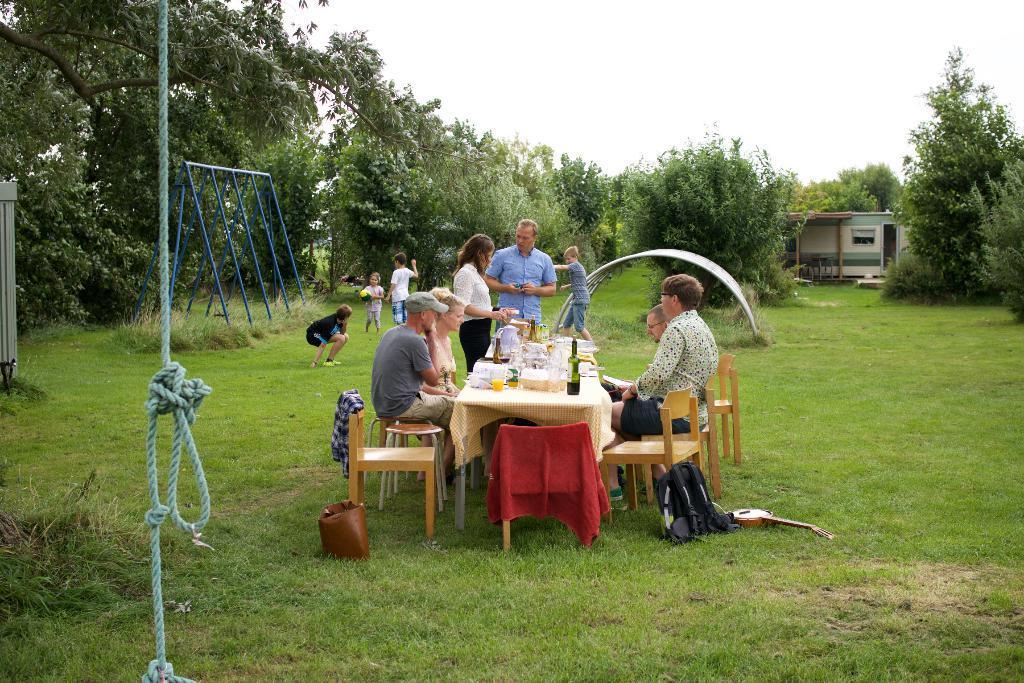In one or two sentences, can you explain what this image depicts? In the center of the image there is a table and we can see bottles, glasses and some objects placed on the table and we can see people sitting around the table. In the background there are people standing and some of them are playing. At the bottom we can see bags and a guitar placed on the grass. On the left there is a rope. In the background there are trees and a shed. At the top there is sky. 